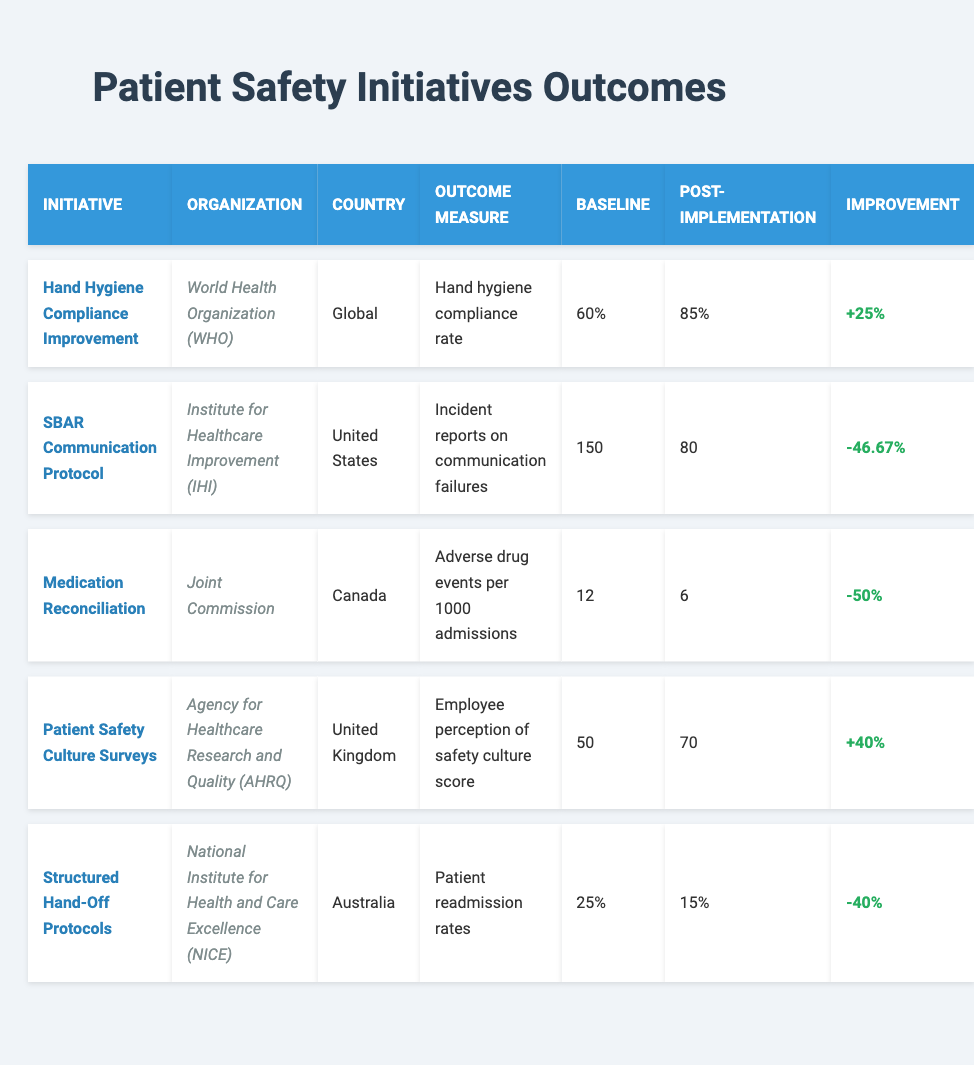What was the baseline hand hygiene compliance rate for the initiative implemented by WHO? The table indicates that the baseline compliance rate for the "Hand Hygiene Compliance Improvement" initiative was 60%. This value is directly listed under the "Baseline" column for this initiative.
Answer: 60% How many adverse drug events per 1000 admissions were recorded post-implementation of the Medication Reconciliation initiative? The table shows that the post-implementation adverse drug events per 1000 admissions for the "Medication Reconciliation" initiative was 6. This is located in the "Post-Implementation" column for that row.
Answer: 6 What improvement percentage was achieved for the Patient Safety Culture Surveys? To find the improvement percentage for the "Patient Safety Culture Surveys," you need to compare the post-implementation score (70) to the baseline score (50). The improvement is calculated: (70 - 50) / 50 * 100 = 40%. This value is listed in the "Improvement" column for that initiative.
Answer: +40% Which initiative resulted in the lowest number of incidents reported on communication failures after implementation? The "SBAR Communication Protocol" initiative resulted in the lowest number of incidents reported (80) after implementation. By comparing all post-implementation incidents noted in the table, this was the minimum.
Answer: SBAR Communication Protocol What is the average baseline readmission rate across all initiatives listed in the table? The baseline readmission rates are as follows: Hand Hygiene (N/A), SBAR (N/A), Medication Reconciliation (N/A), Patient Safety Culture (N/A), and Structured Hand-Off (25%). Since only one initiative provides a baseline readmission rate, the average is simply 25%.
Answer: 25% Is the post-implementation compliance rate higher than the baseline for all initiatives listed? To determine this, we must compare both rates for each initiative. The “Hand Hygiene Compliance Improvement” improved from 60% to 85%, “Medication Reconciliation” improved from 12 to 6 (lower), “Patient Safety Culture Surveys” from 50 to 70 (higher), and “Structured Hand-Off Protocols” from 25% to 15% (lower). Therefore, not all initiatives show a post-implementation compliance rate higher than the baseline.
Answer: No Which patient safety initiative showed the maximum improvement in its outcome measure? The "Hand Hygiene Compliance Improvement" showed the maximum improvement of 25 percentage points (from 60% to 85%). Other initiatives were either measured in counts or showed less improvement than this initiative.
Answer: Hand Hygiene Compliance Improvement What was the outcome measure used for the initiative implemented by AHRQ in the UK? The outcome measure for the "Patient Safety Culture Surveys" initiative implemented by the AHRQ in the UK was the "Employee perception of safety culture score." This is located under the "Outcome Measure" column for that initiative.
Answer: Employee perception of safety culture score Calculate the percentage reduction in adverse drug events per 1000 admissions due to the Medication Reconciliation initiative. The baseline was 12, and post-implementation it was 6. The reduction is calculated as: (12 - 6) / 12 * 100 = 50%. This shows that the initiative reduced adverse drug events by half, or 50%.
Answer: 50% Was the implementation of the Structured Hand-Off Protocols associated with a higher readmission rate compared to its baseline? The baseline readmission rate was 25%, and the post-implementation rate was 15%. since 15% is lower than the baseline of 25%, it indicates a decrease in readmission rates. Therefore, the implementation was not associated with a higher readmission rate.
Answer: No 